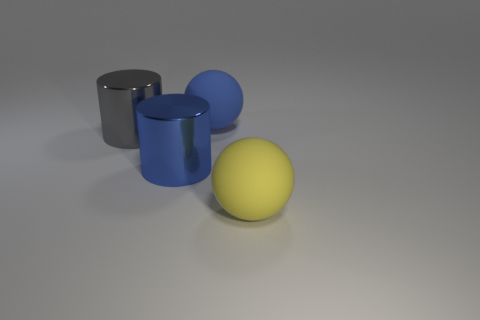Subtract all blue cylinders. How many cylinders are left? 1 Subtract 2 spheres. How many spheres are left? 0 Add 3 large rubber objects. How many objects exist? 7 Subtract all brown blocks. How many gray cylinders are left? 1 Subtract 0 cyan cylinders. How many objects are left? 4 Subtract all cyan spheres. Subtract all yellow cubes. How many spheres are left? 2 Subtract all large purple matte blocks. Subtract all large metallic cylinders. How many objects are left? 2 Add 2 blue matte spheres. How many blue matte spheres are left? 3 Add 2 large gray things. How many large gray things exist? 3 